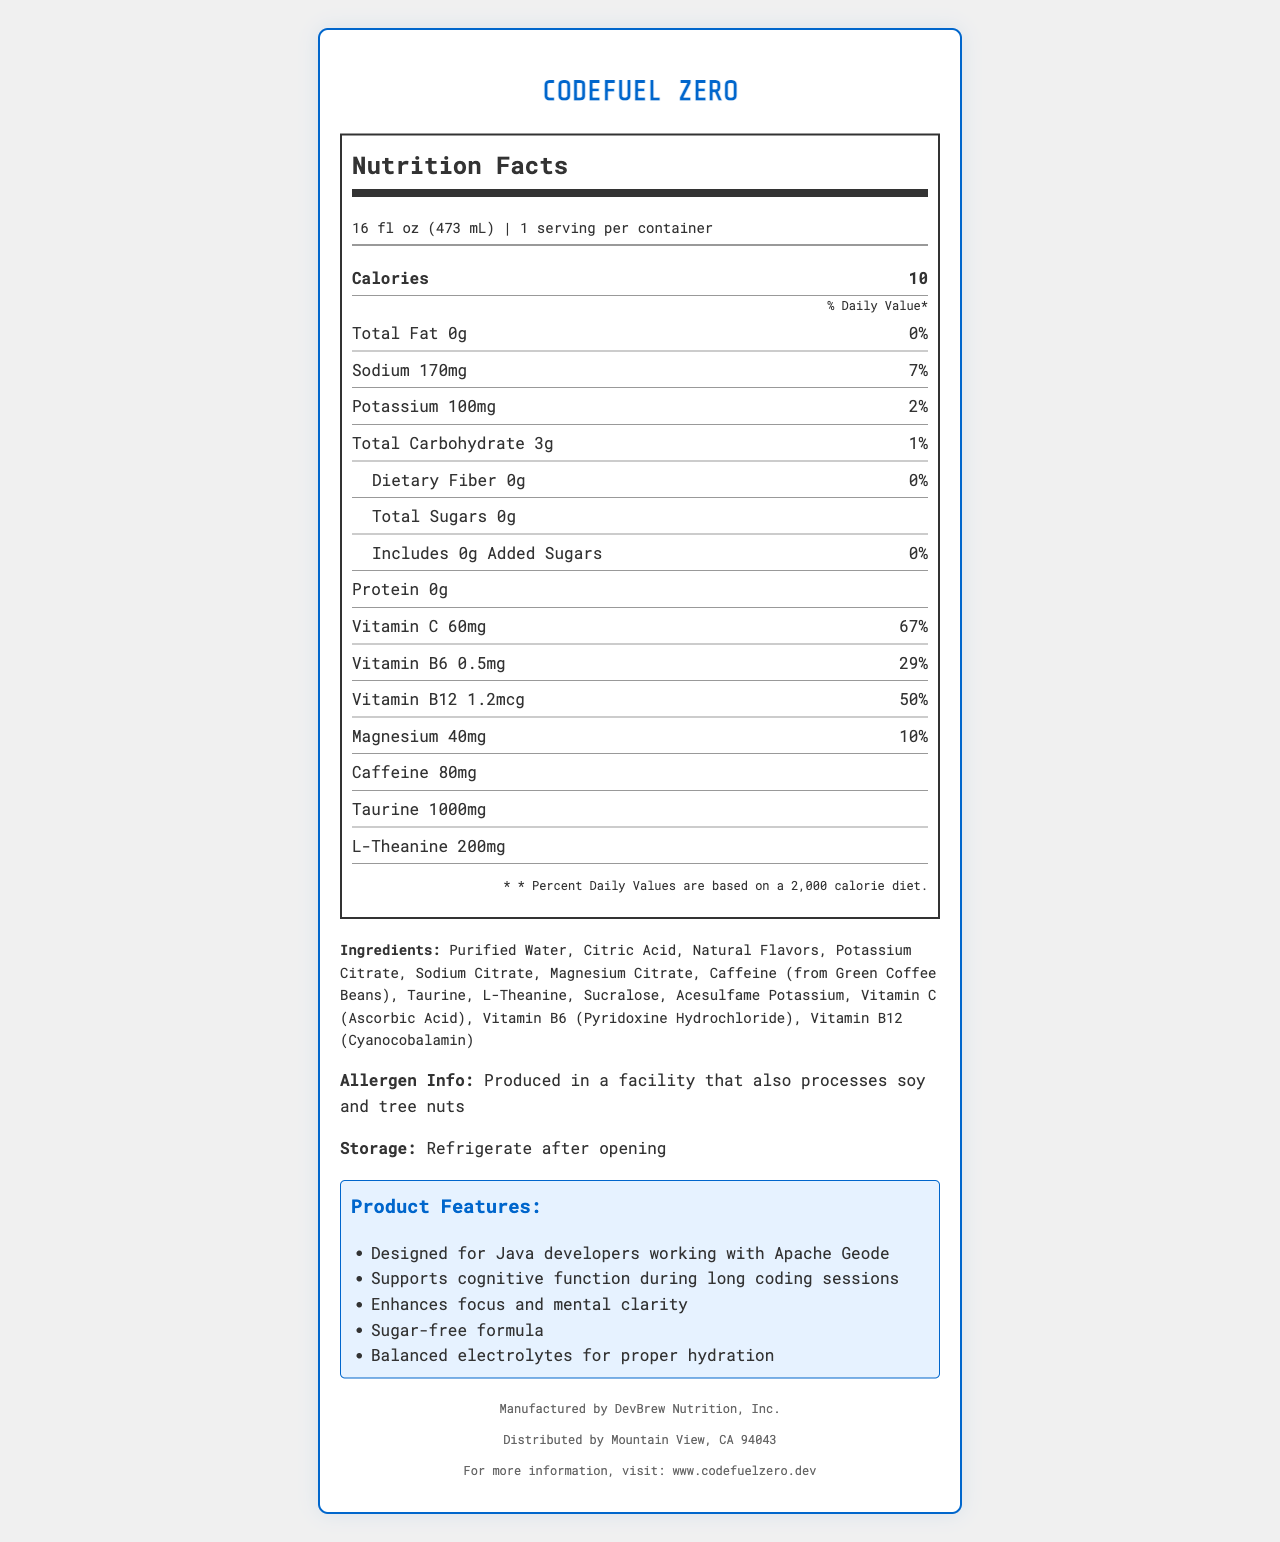what is the serving size of CodeFuel Zero? The serving size is clearly mentioned at the top of the nutrition label below the product name.
Answer: 16 fl oz (473 mL) how many calories are in a serving? The number of calories per serving is listed prominently in the nutrient section of the label.
Answer: 10 what percentage of the daily value of sodium does one serving contain? The daily value percentage for sodium is provided next to the sodium content in milligrams.
Answer: 7% how much caffeine does CodeFuel Zero contain? The amount of caffeine in milligrams is listed in the nutrient section.
Answer: 80 mg what vitamins are included in CodeFuel Zero, and what are their daily value percentages? The vitamins and their daily value percentages are visible in the nutrient section, including Vitamin C, Vitamin B6, and Vitamin B12.
Answer: Vitamin C (67%), Vitamin B6 (29%), Vitamin B12 (50%) how many grams of total sugars does CodeFuel Zero contain? The total sugars content is listed as 0 grams in the nutrient section of the label.
Answer: 0 grams what ingredients are in CodeFuel Zero? The list of ingredients is provided towards the bottom of the document.
Answer: Purified Water, Citric Acid, Natural Flavors, Potassium Citrate, Sodium Citrate, Magnesium Citrate, Caffeine (from Green Coffee Beans), Taurine, L-Theanine, Sucralose, Acesulfame Potassium, Vitamin C (Ascorbic Acid), Vitamin B6 (Pyridoxine Hydrochloride), Vitamin B12 (Cyanocobalamin) who manufactures CodeFuel Zero? The manufacturer information is listed at the bottom of the document.
Answer: DevBrew Nutrition, Inc. what are some key marketing claims for CodeFuel Zero? The marketing claims are presented prominently in the document's marketing claims section.
Answer: Designed for Java developers working with Apache Geode, Supports cognitive function during long coding sessions, Enhances focus and mental clarity, Sugar-free formula, Balanced electrolytes for proper hydration which of the following claims is NOT a marketing claim for CodeFuel Zero? A. Supports cognitive function during long coding sessions B. High in protein C. Sugar-free formula The document does not mention high protein content as a claim. The other claims are listed in the marketing claims section.
Answer: B what percentage of the daily value of magnesium does CodeFuel Zero provide? I. 5% II. 10% III. 15% IV. 20% The daily value percentage for magnesium is listed as 10% in the nutrient section.
Answer: II. 10% is CodeFuel Zero sugar-free? The product is labeled as sugar-free, and the nutrient section lists 0 grams of total sugars and added sugars.
Answer: Yes does the beverage contain allergens? The allergen information is listed right below the ingredients section.
Answer: Produced in a facility that also processes soy and tree nuts provide a summary of the CodeFuel Zero sports drink's nutrition facts and features. This summary combines information from the nutrition facts, ingredient list, and the marketing claims sections of the document.
Answer: CodeFuel Zero is a sugar-free, electrolyte-rich sports drink designed for Java developers. Each 16 fl oz serving contains 10 calories, 0g fat, 3g carbohydrates, 0g sugars, 170 mg sodium (7% DV), 100 mg potassium (2% DV), 60 mg Vitamin C (67% DV), 0.5 mg Vitamin B6 (29% DV), 1.2 mcg Vitamin B12 (50% DV), and 40 mg magnesium (10% DV). It includes ingredients like purified water, citric acid, natural flavors, various electrolytes, caffeine from green coffee beans, taurine, and L-Theanine. The product aims to support cognitive function, focus, and hydration during long coding sessions. what is the price per serving of CodeFuel Zero? The document does not provide any information about the price of the product.
Answer: Not enough information 